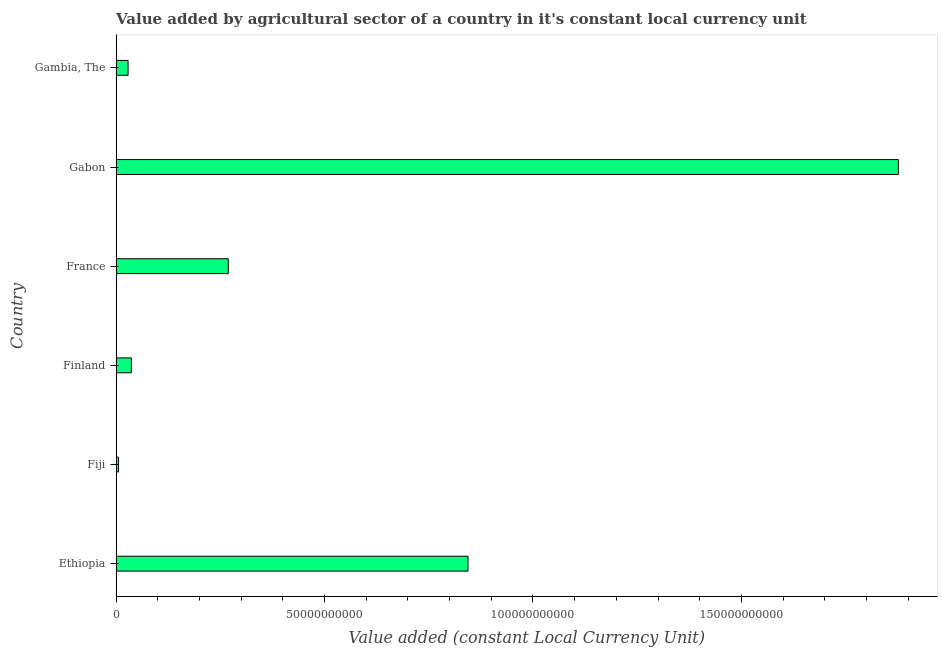Does the graph contain any zero values?
Provide a succinct answer. No. Does the graph contain grids?
Make the answer very short. No. What is the title of the graph?
Keep it short and to the point. Value added by agricultural sector of a country in it's constant local currency unit. What is the label or title of the X-axis?
Provide a succinct answer. Value added (constant Local Currency Unit). What is the label or title of the Y-axis?
Your answer should be very brief. Country. What is the value added by agriculture sector in Ethiopia?
Your answer should be compact. 8.44e+1. Across all countries, what is the maximum value added by agriculture sector?
Your answer should be very brief. 1.88e+11. Across all countries, what is the minimum value added by agriculture sector?
Your response must be concise. 5.80e+08. In which country was the value added by agriculture sector maximum?
Make the answer very short. Gabon. In which country was the value added by agriculture sector minimum?
Give a very brief answer. Fiji. What is the sum of the value added by agriculture sector?
Give a very brief answer. 3.06e+11. What is the difference between the value added by agriculture sector in France and Gabon?
Ensure brevity in your answer.  -1.61e+11. What is the average value added by agriculture sector per country?
Your response must be concise. 5.10e+1. What is the median value added by agriculture sector?
Provide a short and direct response. 1.53e+1. What is the ratio of the value added by agriculture sector in Fiji to that in Gabon?
Provide a succinct answer. 0. Is the difference between the value added by agriculture sector in Finland and France greater than the difference between any two countries?
Your response must be concise. No. What is the difference between the highest and the second highest value added by agriculture sector?
Offer a very short reply. 1.03e+11. What is the difference between the highest and the lowest value added by agriculture sector?
Your answer should be very brief. 1.87e+11. In how many countries, is the value added by agriculture sector greater than the average value added by agriculture sector taken over all countries?
Make the answer very short. 2. Are all the bars in the graph horizontal?
Your answer should be compact. Yes. What is the difference between two consecutive major ticks on the X-axis?
Provide a succinct answer. 5.00e+1. Are the values on the major ticks of X-axis written in scientific E-notation?
Your answer should be compact. No. What is the Value added (constant Local Currency Unit) of Ethiopia?
Provide a short and direct response. 8.44e+1. What is the Value added (constant Local Currency Unit) of Fiji?
Offer a terse response. 5.80e+08. What is the Value added (constant Local Currency Unit) of Finland?
Your response must be concise. 3.66e+09. What is the Value added (constant Local Currency Unit) of France?
Your answer should be compact. 2.69e+1. What is the Value added (constant Local Currency Unit) of Gabon?
Your answer should be very brief. 1.88e+11. What is the Value added (constant Local Currency Unit) in Gambia, The?
Provide a succinct answer. 2.86e+09. What is the difference between the Value added (constant Local Currency Unit) in Ethiopia and Fiji?
Provide a succinct answer. 8.38e+1. What is the difference between the Value added (constant Local Currency Unit) in Ethiopia and Finland?
Offer a terse response. 8.07e+1. What is the difference between the Value added (constant Local Currency Unit) in Ethiopia and France?
Keep it short and to the point. 5.75e+1. What is the difference between the Value added (constant Local Currency Unit) in Ethiopia and Gabon?
Provide a short and direct response. -1.03e+11. What is the difference between the Value added (constant Local Currency Unit) in Ethiopia and Gambia, The?
Keep it short and to the point. 8.15e+1. What is the difference between the Value added (constant Local Currency Unit) in Fiji and Finland?
Your answer should be very brief. -3.08e+09. What is the difference between the Value added (constant Local Currency Unit) in Fiji and France?
Your answer should be very brief. -2.63e+1. What is the difference between the Value added (constant Local Currency Unit) in Fiji and Gabon?
Offer a terse response. -1.87e+11. What is the difference between the Value added (constant Local Currency Unit) in Fiji and Gambia, The?
Give a very brief answer. -2.28e+09. What is the difference between the Value added (constant Local Currency Unit) in Finland and France?
Your response must be concise. -2.33e+1. What is the difference between the Value added (constant Local Currency Unit) in Finland and Gabon?
Your response must be concise. -1.84e+11. What is the difference between the Value added (constant Local Currency Unit) in Finland and Gambia, The?
Your answer should be very brief. 7.94e+08. What is the difference between the Value added (constant Local Currency Unit) in France and Gabon?
Make the answer very short. -1.61e+11. What is the difference between the Value added (constant Local Currency Unit) in France and Gambia, The?
Your answer should be compact. 2.40e+1. What is the difference between the Value added (constant Local Currency Unit) in Gabon and Gambia, The?
Provide a short and direct response. 1.85e+11. What is the ratio of the Value added (constant Local Currency Unit) in Ethiopia to that in Fiji?
Offer a terse response. 145.5. What is the ratio of the Value added (constant Local Currency Unit) in Ethiopia to that in Finland?
Give a very brief answer. 23.08. What is the ratio of the Value added (constant Local Currency Unit) in Ethiopia to that in France?
Give a very brief answer. 3.14. What is the ratio of the Value added (constant Local Currency Unit) in Ethiopia to that in Gabon?
Your response must be concise. 0.45. What is the ratio of the Value added (constant Local Currency Unit) in Ethiopia to that in Gambia, The?
Provide a succinct answer. 29.48. What is the ratio of the Value added (constant Local Currency Unit) in Fiji to that in Finland?
Offer a terse response. 0.16. What is the ratio of the Value added (constant Local Currency Unit) in Fiji to that in France?
Offer a terse response. 0.02. What is the ratio of the Value added (constant Local Currency Unit) in Fiji to that in Gabon?
Provide a succinct answer. 0. What is the ratio of the Value added (constant Local Currency Unit) in Fiji to that in Gambia, The?
Ensure brevity in your answer.  0.2. What is the ratio of the Value added (constant Local Currency Unit) in Finland to that in France?
Your response must be concise. 0.14. What is the ratio of the Value added (constant Local Currency Unit) in Finland to that in Gabon?
Your answer should be very brief. 0.02. What is the ratio of the Value added (constant Local Currency Unit) in Finland to that in Gambia, The?
Your response must be concise. 1.28. What is the ratio of the Value added (constant Local Currency Unit) in France to that in Gabon?
Keep it short and to the point. 0.14. What is the ratio of the Value added (constant Local Currency Unit) in France to that in Gambia, The?
Your answer should be very brief. 9.4. What is the ratio of the Value added (constant Local Currency Unit) in Gabon to that in Gambia, The?
Ensure brevity in your answer.  65.54. 